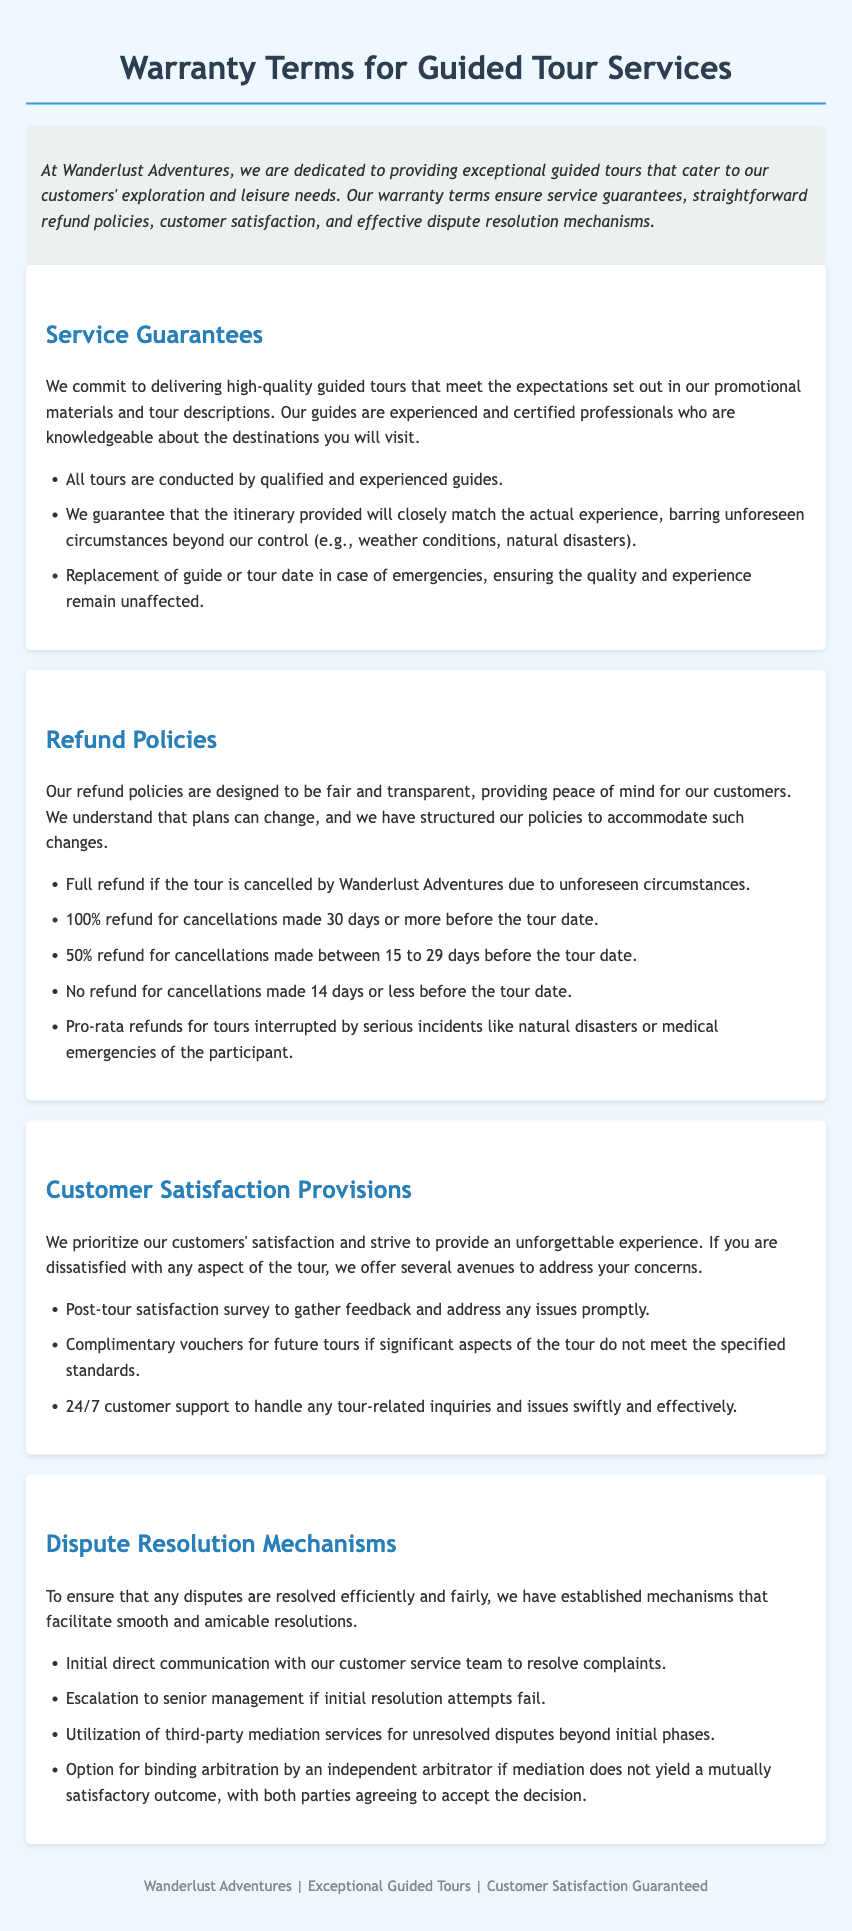What is the company name? The document clearly states the company name at the beginning, which is "Wanderlust Adventures."
Answer: Wanderlust Adventures How many days before the tour date can you cancel for a full refund? The document explicitly mentions that a full refund is available for cancellations made 30 days or more before the tour date.
Answer: 30 days What is the refund percentage for cancellations made between 15 to 29 days? The document specifies that there is a 50% refund for cancellations made between 15 to 29 days before the tour date.
Answer: 50% What type of support is available to customers after the tour? The document indicates that a post-tour satisfaction survey is conducted to gather feedback and address issues, signifying ongoing support.
Answer: Post-tour satisfaction survey What happens if a participant has a medical emergency during the tour? According to the document, there are pro-rata refunds available for tours interrupted by serious incidents like medical emergencies.
Answer: Pro-rata refunds Where can complaints first be directed? The document states that the initial direct communication should be with the customer service team to resolve complaints.
Answer: Customer service team What is required for binding arbitration? The document mentions that both parties must agree to accept the decision of an independent arbitrator for binding arbitration.
Answer: Agreement of both parties What guarantees are provided regarding tour guides? The document assures that all tours are conducted by qualified and experienced guides.
Answer: Qualified and experienced guides 